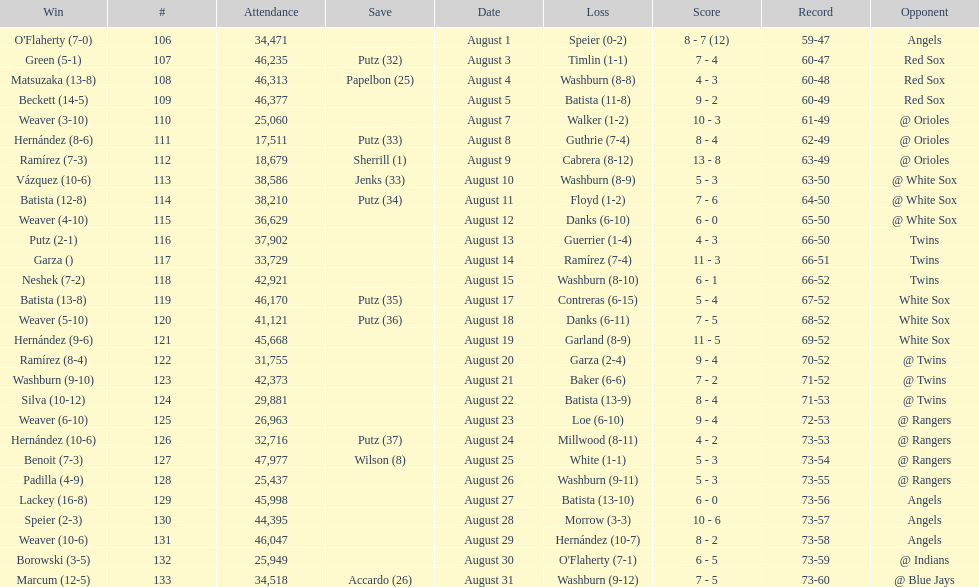Games above 30,000 in attendance 21. 